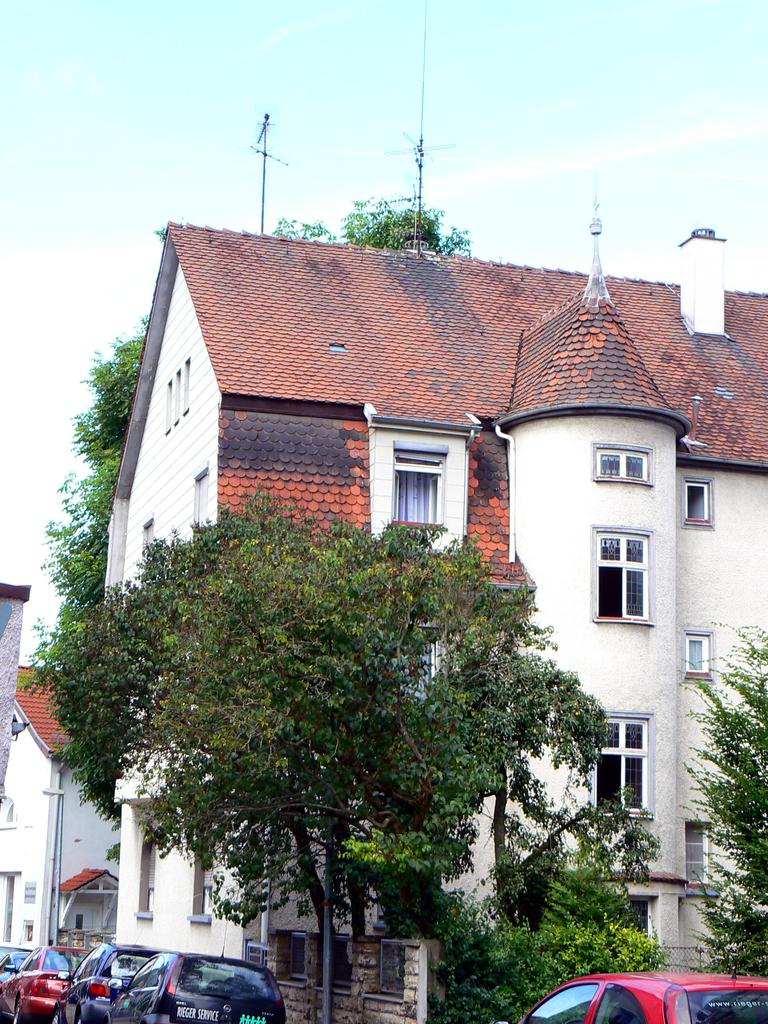What type of structures can be seen in the image? There are buildings in the image. What other natural elements are present in the image? There are trees in the image. Are there any vehicles visible in the image? Yes, there are cars parked in the image. How would you describe the sky in the image? The sky is blue and cloudy in the image. What shape is the development box in the image? There is no development box present in the image. 